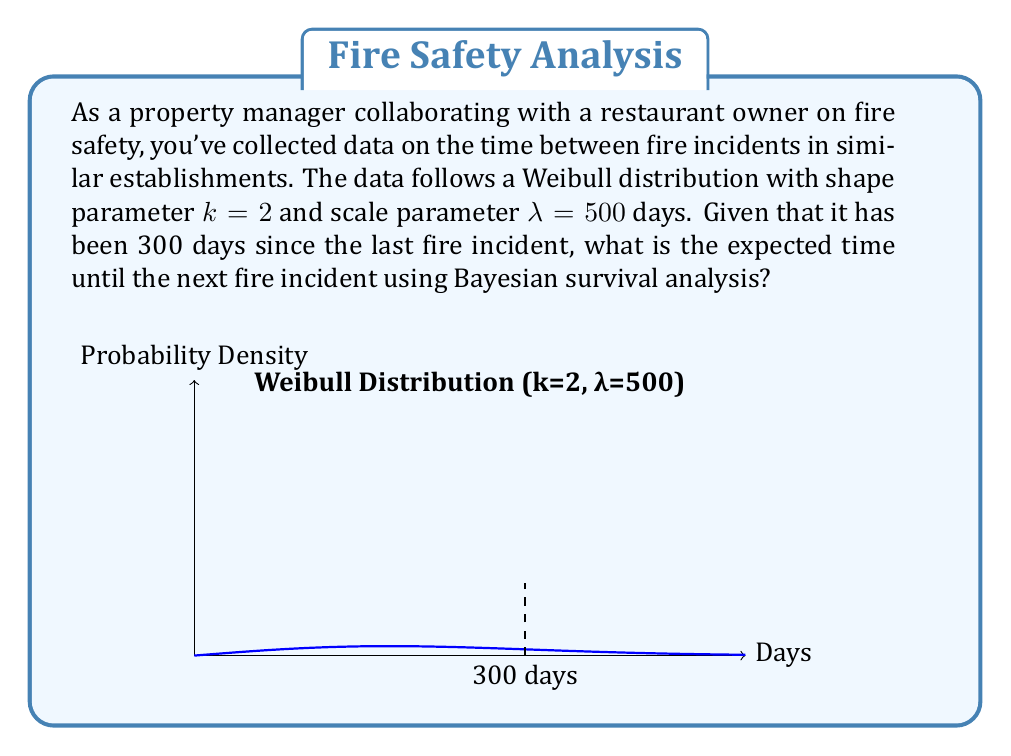What is the answer to this math problem? To solve this problem using Bayesian survival analysis, we'll follow these steps:

1) The survival function for a Weibull distribution is:

   $$S(t) = e^{-(t/\lambda)^k}$$

2) The hazard function is:

   $$h(t) = \frac{k}{\lambda} (\frac{t}{\lambda})^{k-1}$$

3) For a Weibull distribution, the expected additional lifetime given survival to time $t$ is:

   $$E[T-t|T>t] = \lambda \Gamma(1+\frac{1}{k}) \left(\left(\frac{t}{\lambda}\right)^k + 1\right)^{1/k} - t$$

4) Substituting our values ($k=2$, $\lambda=500$, $t=300$):

   $$E[T-300|T>300] = 500 \Gamma(1+\frac{1}{2}) \left(\left(\frac{300}{500}\right)^2 + 1\right)^{1/2} - 300$$

5) Simplify:
   - $\Gamma(1+\frac{1}{2}) = \Gamma(1.5) = \frac{\sqrt{\pi}}{2} \approx 0.886$
   - $\left(\frac{300}{500}\right)^2 = 0.36$
   - $\sqrt{0.36 + 1} \approx 1.166$

6) Calculate:

   $$E[T-300|T>300] = 500 * 0.886 * 1.166 - 300 \approx 216.8$$

Therefore, given that 300 days have passed since the last fire incident, we expect the next fire incident to occur in approximately 216.8 days from now.
Answer: 216.8 days 